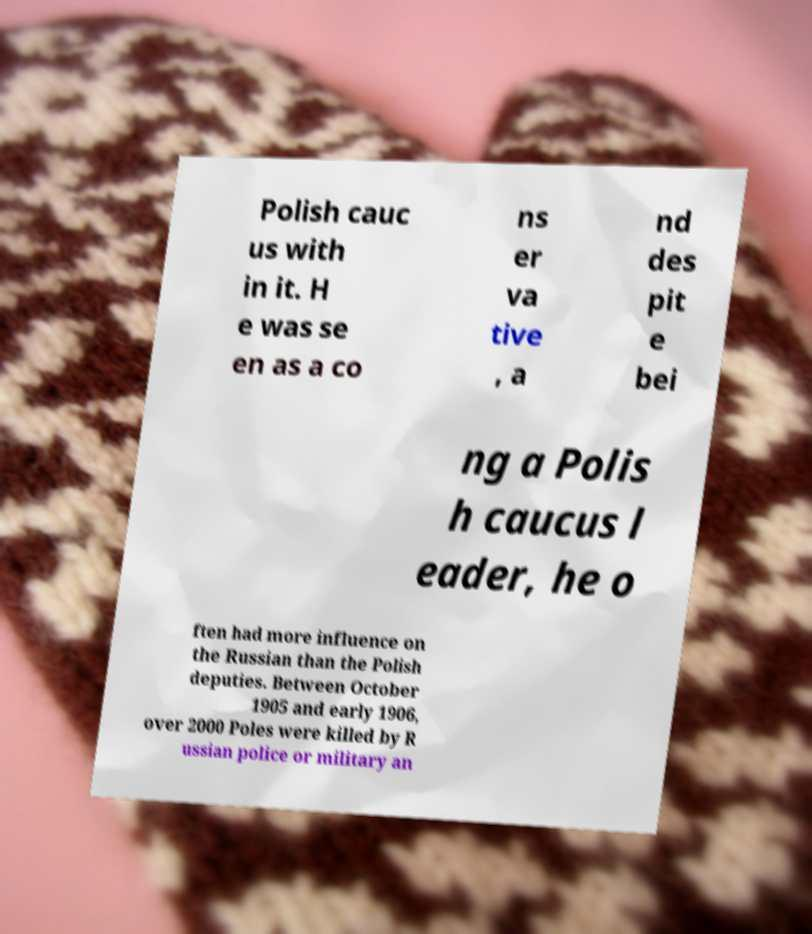I need the written content from this picture converted into text. Can you do that? Polish cauc us with in it. H e was se en as a co ns er va tive , a nd des pit e bei ng a Polis h caucus l eader, he o ften had more influence on the Russian than the Polish deputies. Between October 1905 and early 1906, over 2000 Poles were killed by R ussian police or military an 